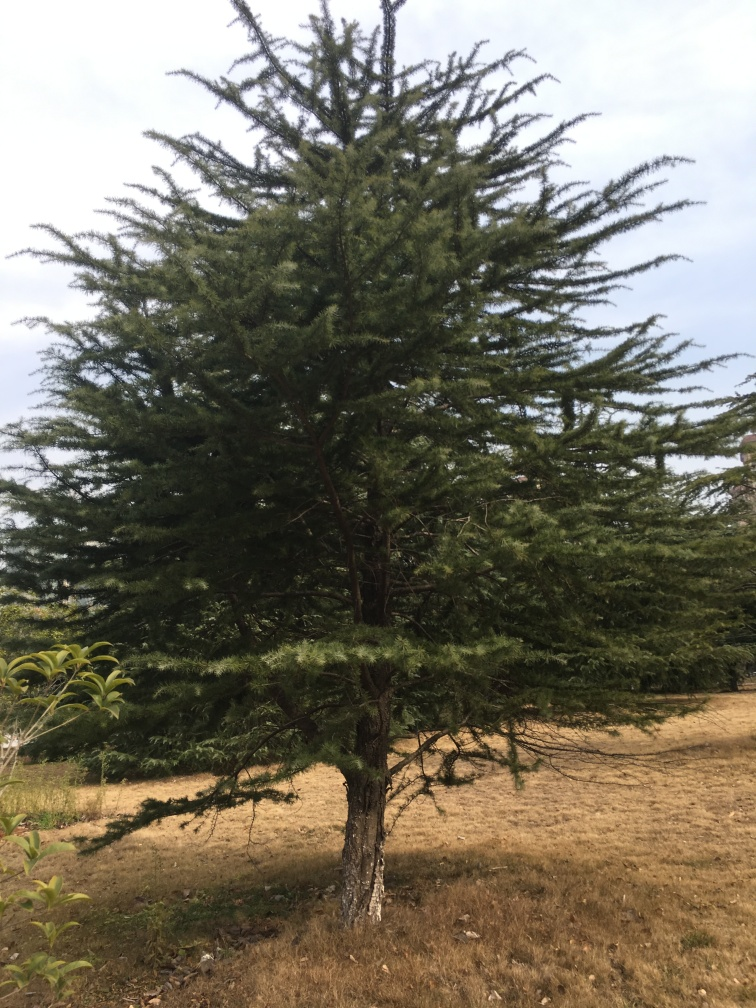Are there any quality issues with this image? The key quality issues with the image include its slight tilt, and the uneven framing, which could have centered the tree better for aesthetic appeal. Moreover, the lighting appears to be flat, which might result from an overcast sky, slightly reducing the visual impact of the image. The resolution and focus seem acceptable; however, the details in the shadowed areas under the tree aren't very clear. 